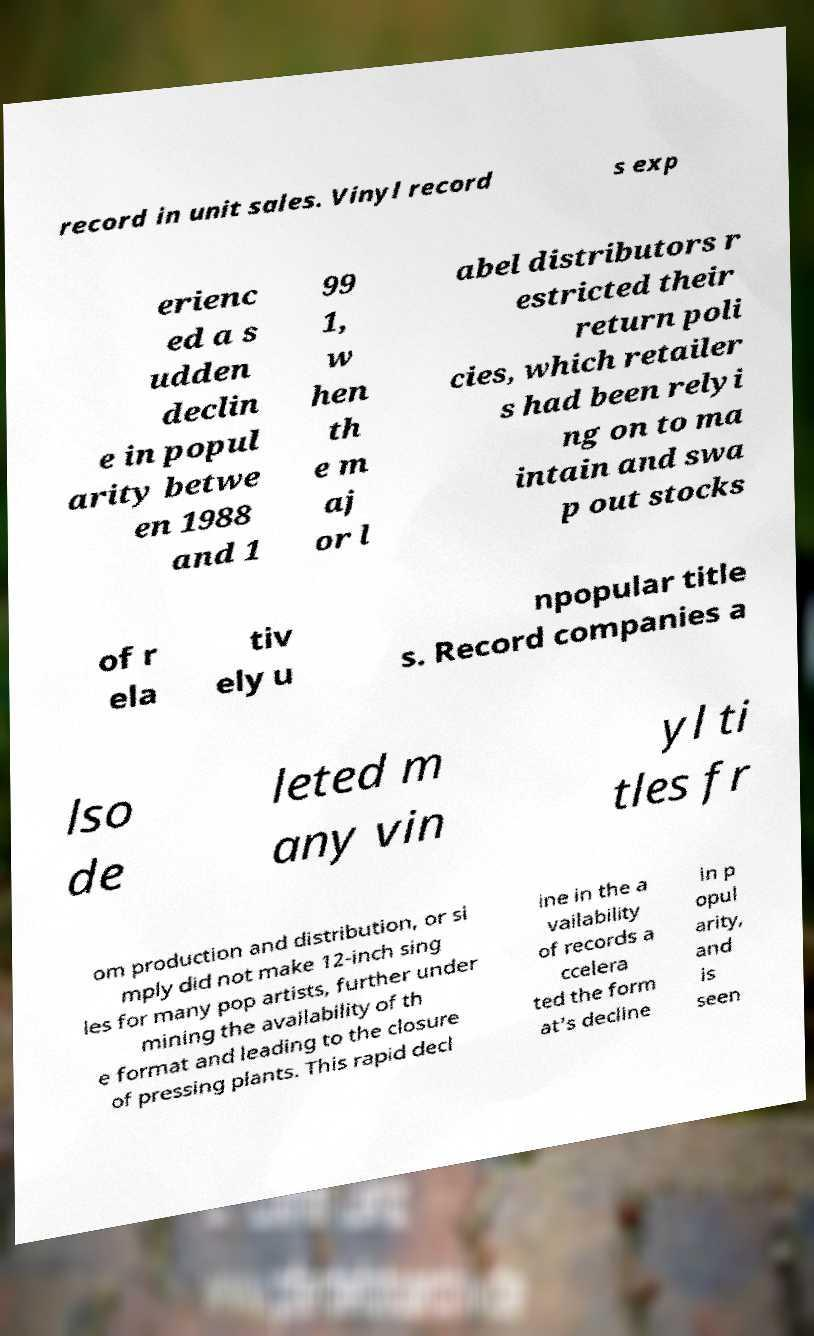Could you assist in decoding the text presented in this image and type it out clearly? record in unit sales. Vinyl record s exp erienc ed a s udden declin e in popul arity betwe en 1988 and 1 99 1, w hen th e m aj or l abel distributors r estricted their return poli cies, which retailer s had been relyi ng on to ma intain and swa p out stocks of r ela tiv ely u npopular title s. Record companies a lso de leted m any vin yl ti tles fr om production and distribution, or si mply did not make 12-inch sing les for many pop artists, further under mining the availability of th e format and leading to the closure of pressing plants. This rapid decl ine in the a vailability of records a ccelera ted the form at's decline in p opul arity, and is seen 